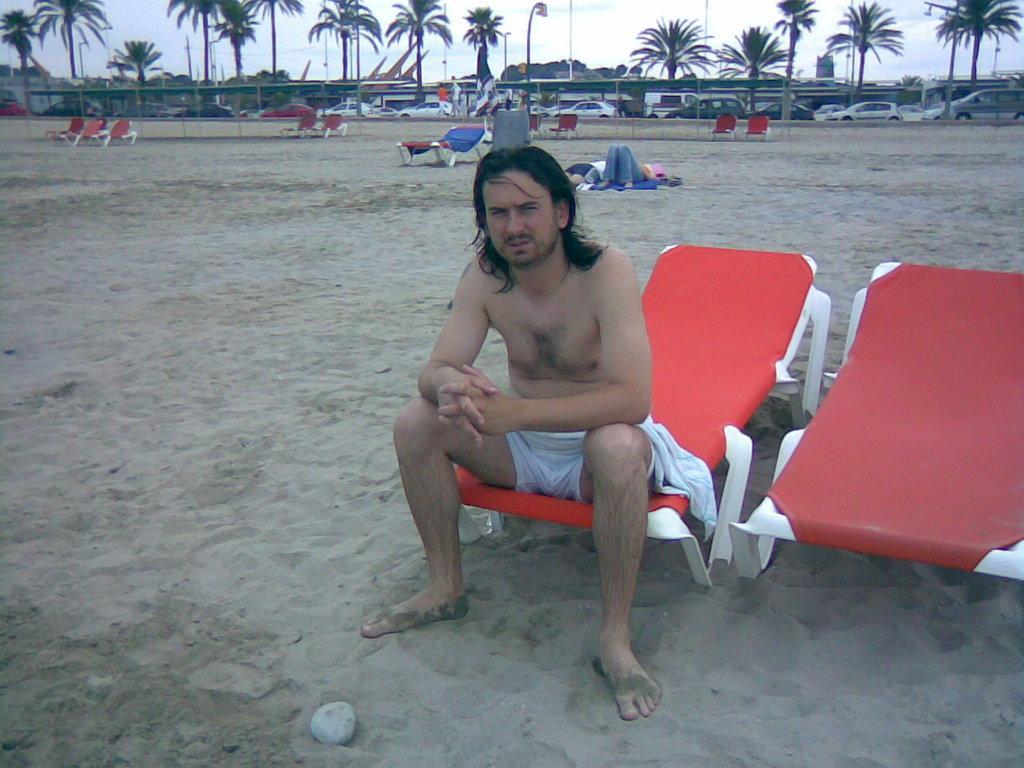Can you describe this image briefly? This man is sitting on a red chair. Far there are vehicles and trees. 